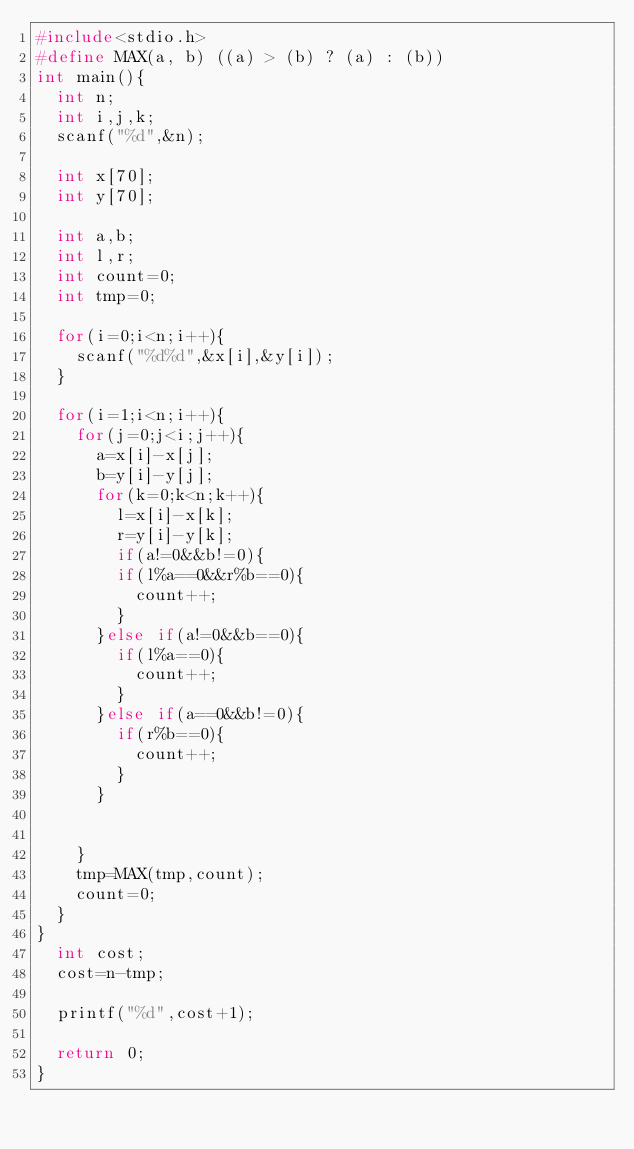<code> <loc_0><loc_0><loc_500><loc_500><_C_>#include<stdio.h>
#define MAX(a, b) ((a) > (b) ? (a) : (b))
int main(){
  int n;
  int i,j,k;
  scanf("%d",&n);

  int x[70];
  int y[70];

  int a,b;
  int l,r;
  int count=0;
  int tmp=0;

  for(i=0;i<n;i++){
    scanf("%d%d",&x[i],&y[i]);
  }

  for(i=1;i<n;i++){
    for(j=0;j<i;j++){
      a=x[i]-x[j];
      b=y[i]-y[j];
      for(k=0;k<n;k++){
        l=x[i]-x[k];
        r=y[i]-y[k];
        if(a!=0&&b!=0){
        if(l%a==0&&r%b==0){
          count++;
        }
      }else if(a!=0&&b==0){
        if(l%a==0){
          count++;
        }
      }else if(a==0&&b!=0){
        if(r%b==0){
          count++;
        }
      }


    }
    tmp=MAX(tmp,count);
    count=0;
  }
}
  int cost;
  cost=n-tmp;

  printf("%d",cost+1);

  return 0;
}
</code> 